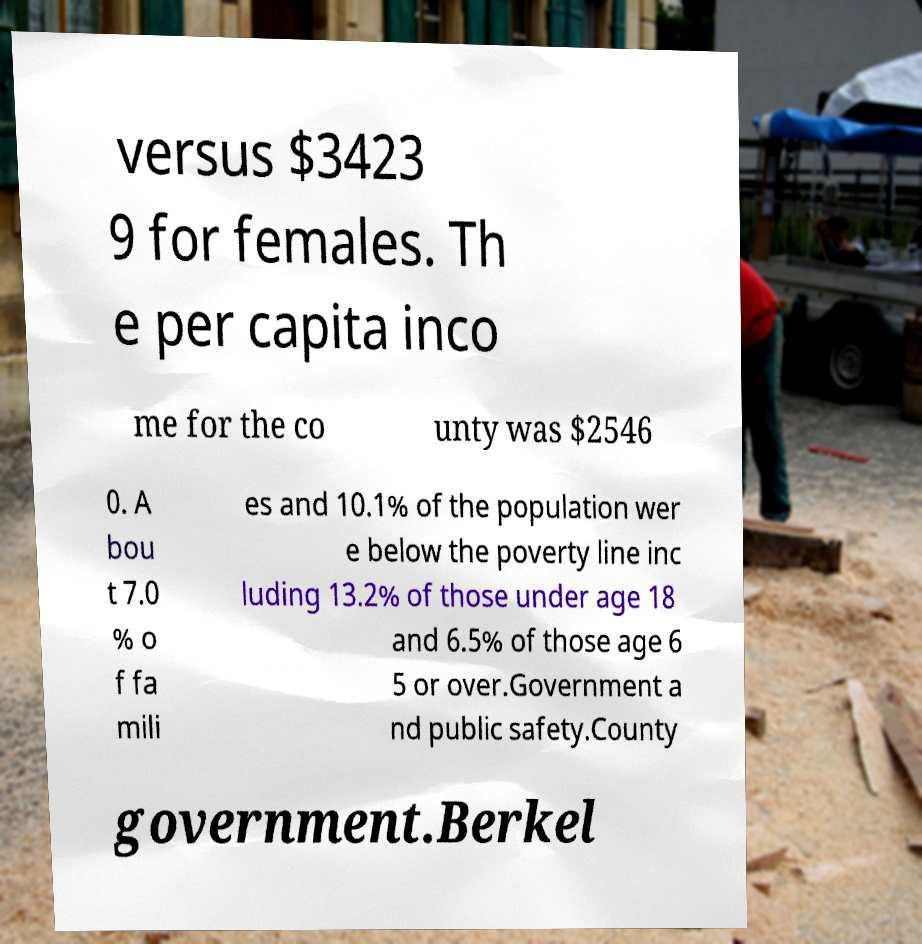Please read and relay the text visible in this image. What does it say? versus $3423 9 for females. Th e per capita inco me for the co unty was $2546 0. A bou t 7.0 % o f fa mili es and 10.1% of the population wer e below the poverty line inc luding 13.2% of those under age 18 and 6.5% of those age 6 5 or over.Government a nd public safety.County government.Berkel 